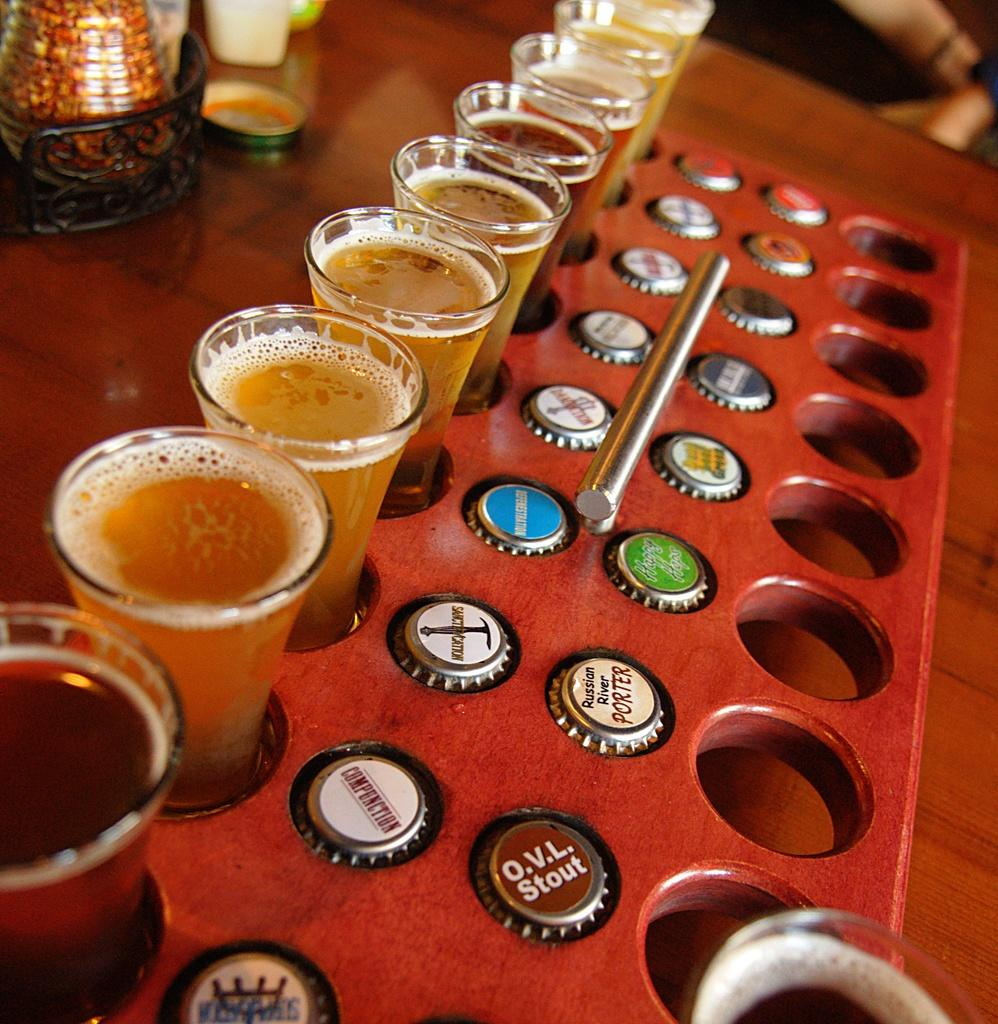What objects are present in the image? There are glasses and bottle caps in the image. How are the glasses and bottle caps arranged? The glasses and bottle caps are in a tray. What is the tray placed on? The tray is on a table. Is there a winter stream visible in the image? No, there is no winter stream present in the image. The image only contains glasses, bottle caps, a tray, and a table. 